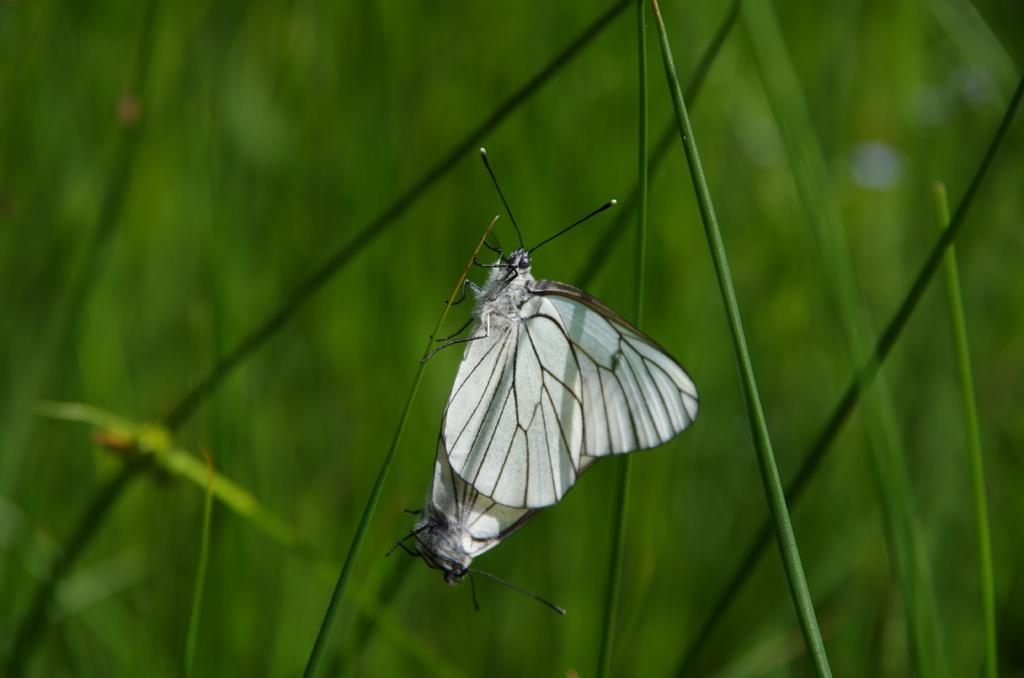What is the main subject of the image? There is a butterfly in the image. Where is the butterfly located? The butterfly is on a stem. What can be seen in the background of the image? There are plants in the background of the image. What type of peace symbol can be seen on the butterfly's wing in the image? There is no peace symbol present on the butterfly's wing in the image. What direction is the butterfly facing in the image? The image does not provide information about the direction the butterfly is facing. 